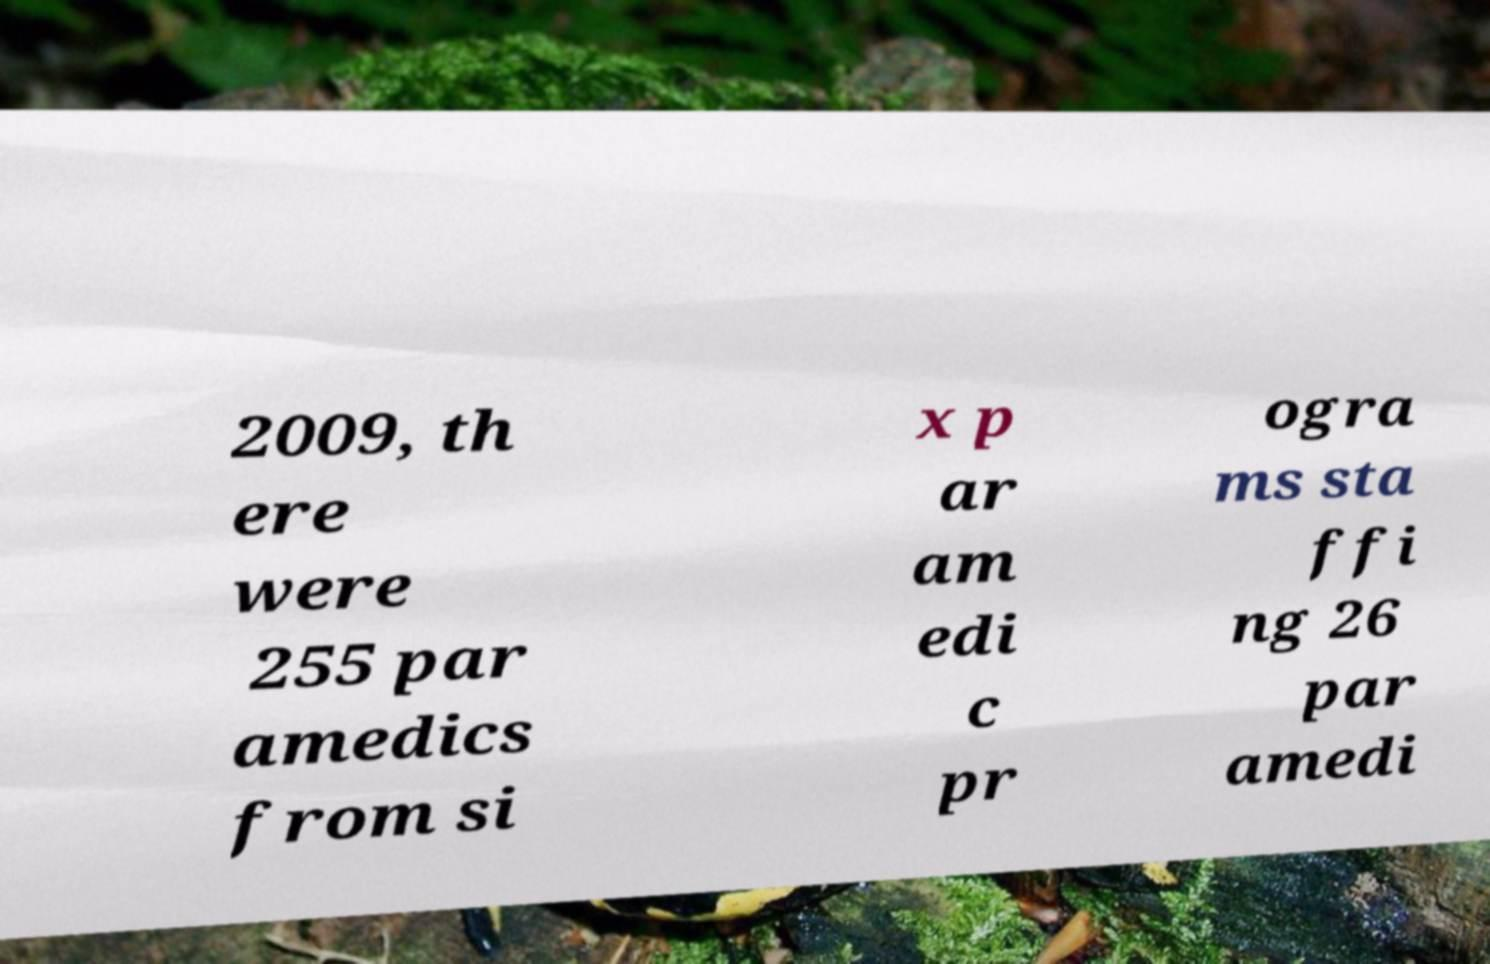There's text embedded in this image that I need extracted. Can you transcribe it verbatim? 2009, th ere were 255 par amedics from si x p ar am edi c pr ogra ms sta ffi ng 26 par amedi 